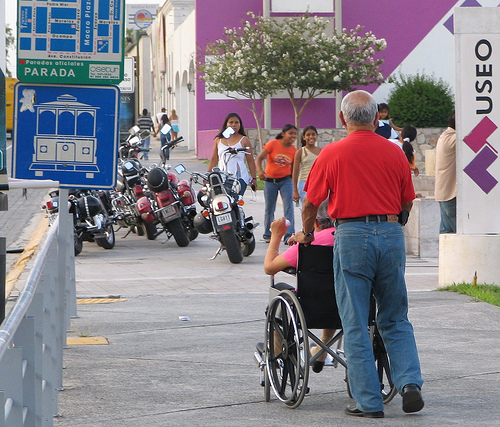<image>
Is there a man next to the bike? No. The man is not positioned next to the bike. They are located in different areas of the scene. Is there a girl in front of the old man? Yes. The girl is positioned in front of the old man, appearing closer to the camera viewpoint. 